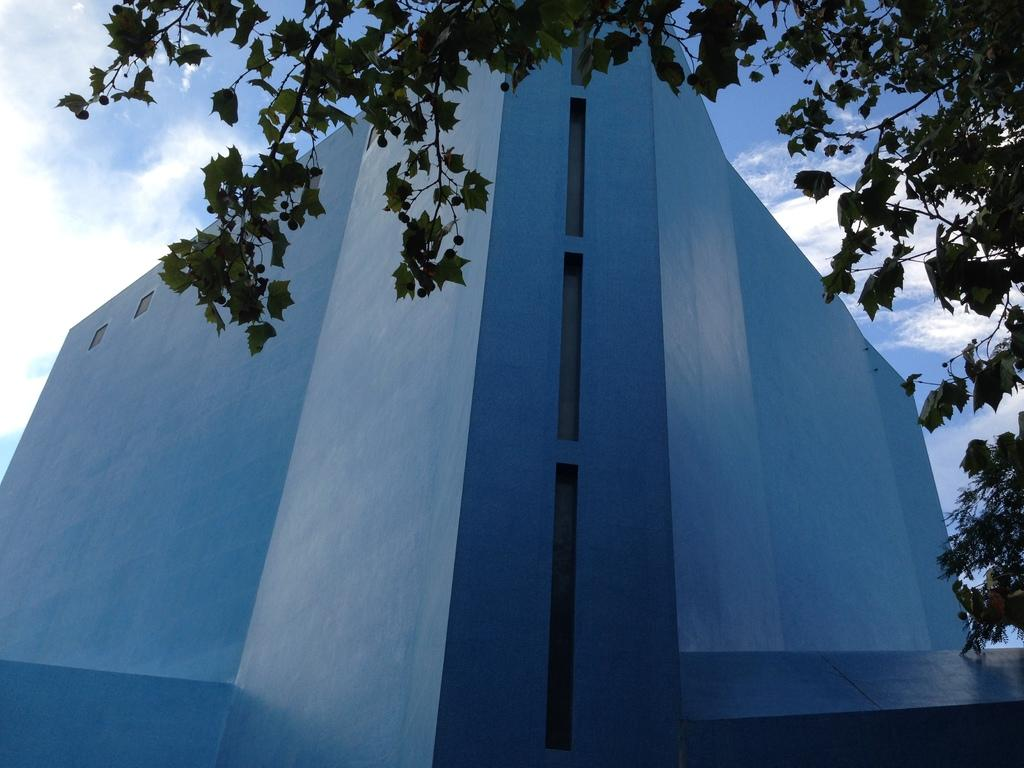What type of structure is present in the image? There is a building in the image. What other natural elements can be seen in the image? There are trees in the image. What can be seen in the distance in the image? The sky is visible in the background of the image. What type of scent can be detected from the trees in the image? There is no information about the scent of the trees in the image, so it cannot be determined. 